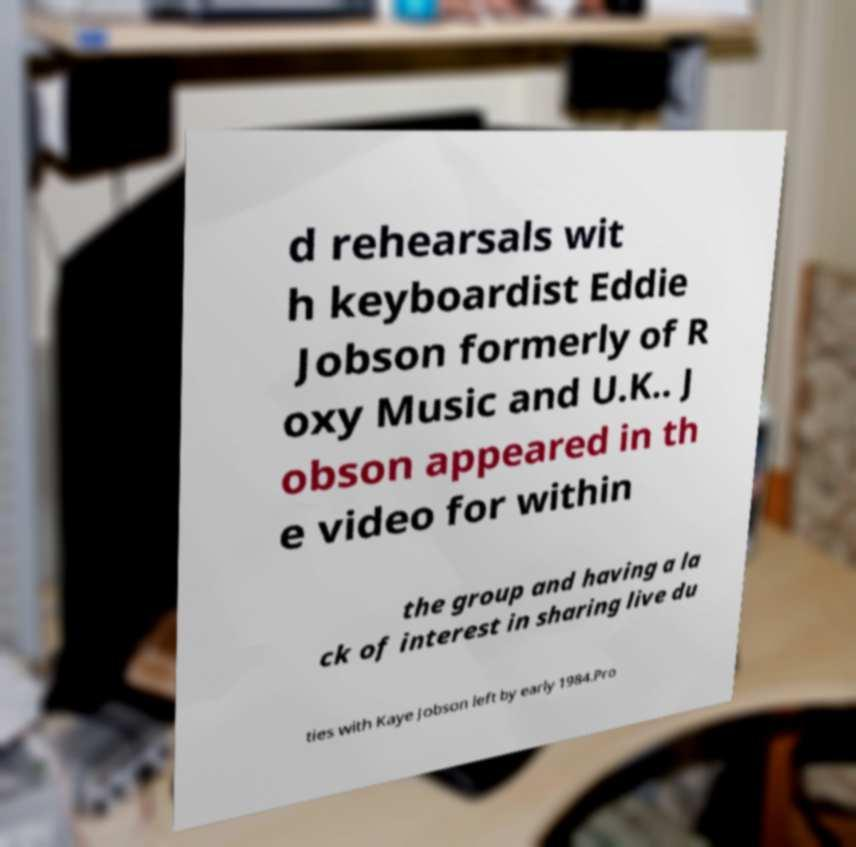I need the written content from this picture converted into text. Can you do that? d rehearsals wit h keyboardist Eddie Jobson formerly of R oxy Music and U.K.. J obson appeared in th e video for within the group and having a la ck of interest in sharing live du ties with Kaye Jobson left by early 1984.Pro 